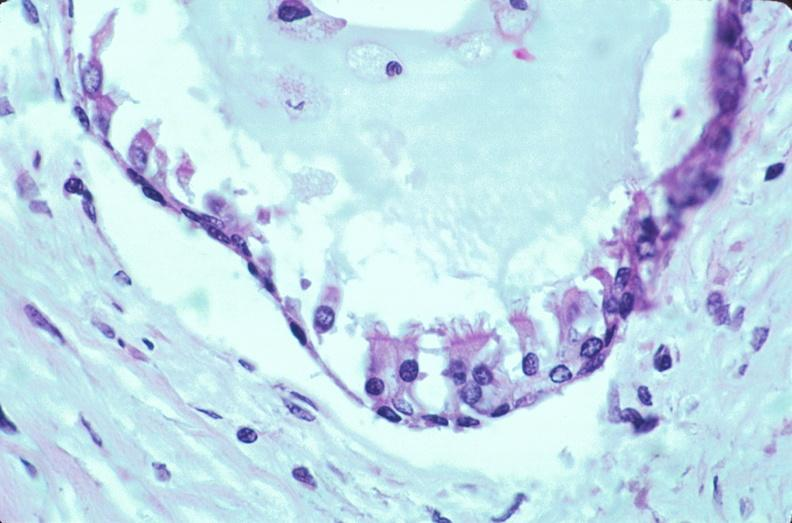what is present?
Answer the question using a single word or phrase. Embryo-fetus 